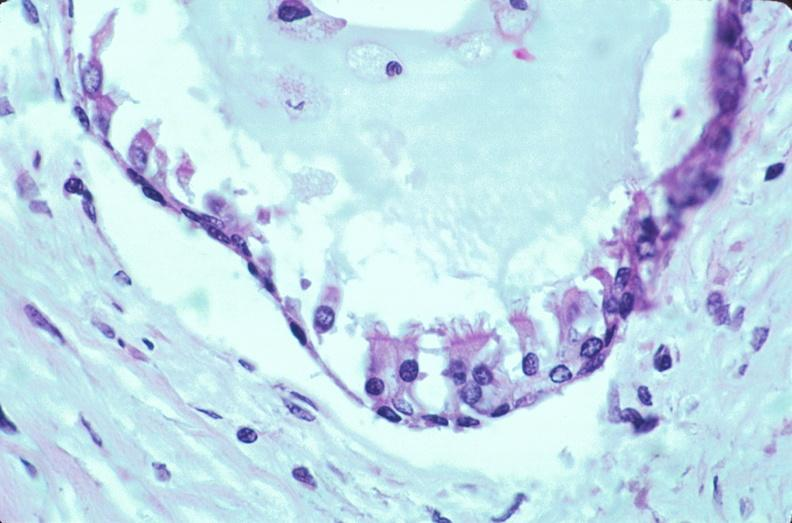what is present?
Answer the question using a single word or phrase. Embryo-fetus 